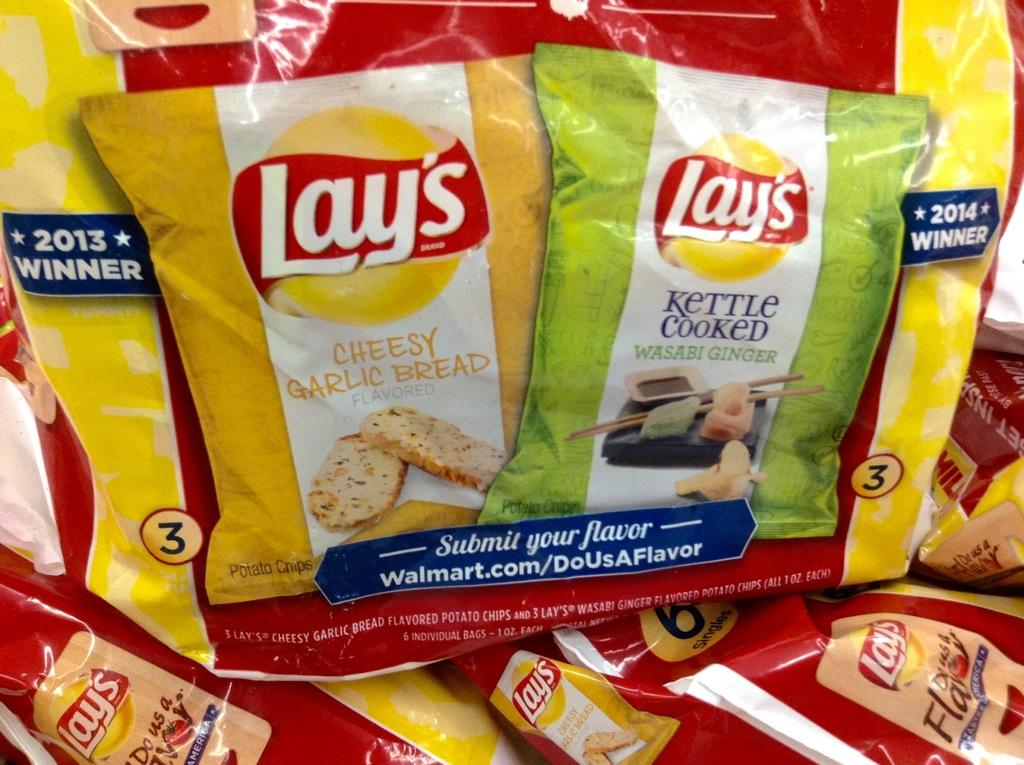What objects are present in the image? There are packets in the image. How many trees are visible in the image? There are no trees visible in the image; it only contains packets. Are there any chairs present in the image? There is no mention of chairs in the provided facts, so we cannot determine if any are present. 